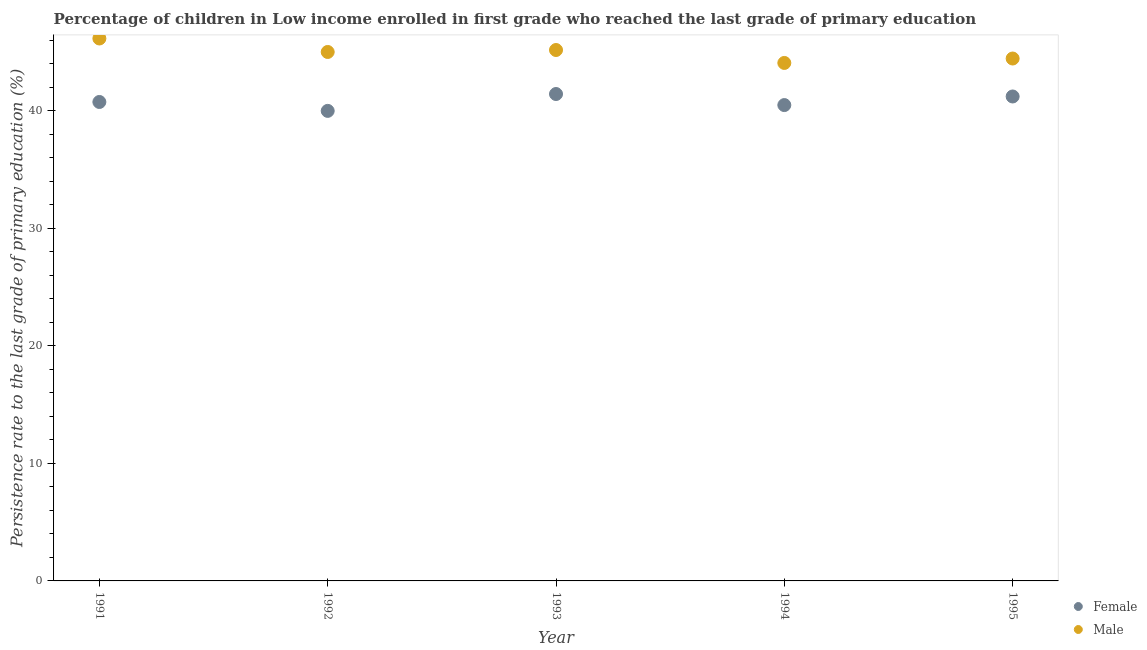Is the number of dotlines equal to the number of legend labels?
Ensure brevity in your answer.  Yes. What is the persistence rate of female students in 1995?
Your answer should be very brief. 41.22. Across all years, what is the maximum persistence rate of female students?
Provide a succinct answer. 41.43. Across all years, what is the minimum persistence rate of male students?
Your answer should be compact. 44.08. In which year was the persistence rate of male students maximum?
Make the answer very short. 1991. What is the total persistence rate of male students in the graph?
Offer a very short reply. 224.88. What is the difference between the persistence rate of male students in 1993 and that in 1994?
Your answer should be compact. 1.1. What is the difference between the persistence rate of male students in 1994 and the persistence rate of female students in 1992?
Provide a short and direct response. 4.08. What is the average persistence rate of male students per year?
Give a very brief answer. 44.98. In the year 1993, what is the difference between the persistence rate of female students and persistence rate of male students?
Offer a terse response. -3.74. In how many years, is the persistence rate of female students greater than 30 %?
Keep it short and to the point. 5. What is the ratio of the persistence rate of female students in 1991 to that in 1994?
Make the answer very short. 1.01. Is the difference between the persistence rate of male students in 1994 and 1995 greater than the difference between the persistence rate of female students in 1994 and 1995?
Provide a short and direct response. Yes. What is the difference between the highest and the second highest persistence rate of male students?
Make the answer very short. 0.98. What is the difference between the highest and the lowest persistence rate of female students?
Your response must be concise. 1.44. Is the persistence rate of male students strictly greater than the persistence rate of female students over the years?
Offer a terse response. Yes. How many dotlines are there?
Provide a succinct answer. 2. What is the difference between two consecutive major ticks on the Y-axis?
Provide a succinct answer. 10. Are the values on the major ticks of Y-axis written in scientific E-notation?
Provide a succinct answer. No. How many legend labels are there?
Your response must be concise. 2. How are the legend labels stacked?
Ensure brevity in your answer.  Vertical. What is the title of the graph?
Offer a terse response. Percentage of children in Low income enrolled in first grade who reached the last grade of primary education. What is the label or title of the Y-axis?
Your response must be concise. Persistence rate to the last grade of primary education (%). What is the Persistence rate to the last grade of primary education (%) in Female in 1991?
Provide a short and direct response. 40.76. What is the Persistence rate to the last grade of primary education (%) in Male in 1991?
Provide a short and direct response. 46.16. What is the Persistence rate to the last grade of primary education (%) of Female in 1992?
Give a very brief answer. 40. What is the Persistence rate to the last grade of primary education (%) in Male in 1992?
Ensure brevity in your answer.  45.01. What is the Persistence rate to the last grade of primary education (%) in Female in 1993?
Your answer should be very brief. 41.43. What is the Persistence rate to the last grade of primary education (%) of Male in 1993?
Give a very brief answer. 45.18. What is the Persistence rate to the last grade of primary education (%) in Female in 1994?
Keep it short and to the point. 40.49. What is the Persistence rate to the last grade of primary education (%) in Male in 1994?
Provide a short and direct response. 44.08. What is the Persistence rate to the last grade of primary education (%) in Female in 1995?
Provide a succinct answer. 41.22. What is the Persistence rate to the last grade of primary education (%) in Male in 1995?
Give a very brief answer. 44.45. Across all years, what is the maximum Persistence rate to the last grade of primary education (%) in Female?
Give a very brief answer. 41.43. Across all years, what is the maximum Persistence rate to the last grade of primary education (%) in Male?
Provide a succinct answer. 46.16. Across all years, what is the minimum Persistence rate to the last grade of primary education (%) of Female?
Keep it short and to the point. 40. Across all years, what is the minimum Persistence rate to the last grade of primary education (%) of Male?
Provide a succinct answer. 44.08. What is the total Persistence rate to the last grade of primary education (%) of Female in the graph?
Offer a terse response. 203.9. What is the total Persistence rate to the last grade of primary education (%) of Male in the graph?
Give a very brief answer. 224.88. What is the difference between the Persistence rate to the last grade of primary education (%) of Female in 1991 and that in 1992?
Your response must be concise. 0.76. What is the difference between the Persistence rate to the last grade of primary education (%) in Male in 1991 and that in 1992?
Your response must be concise. 1.15. What is the difference between the Persistence rate to the last grade of primary education (%) of Female in 1991 and that in 1993?
Make the answer very short. -0.68. What is the difference between the Persistence rate to the last grade of primary education (%) in Female in 1991 and that in 1994?
Ensure brevity in your answer.  0.26. What is the difference between the Persistence rate to the last grade of primary education (%) of Male in 1991 and that in 1994?
Give a very brief answer. 2.08. What is the difference between the Persistence rate to the last grade of primary education (%) in Female in 1991 and that in 1995?
Your response must be concise. -0.47. What is the difference between the Persistence rate to the last grade of primary education (%) in Male in 1991 and that in 1995?
Your answer should be very brief. 1.7. What is the difference between the Persistence rate to the last grade of primary education (%) of Female in 1992 and that in 1993?
Your answer should be compact. -1.44. What is the difference between the Persistence rate to the last grade of primary education (%) in Male in 1992 and that in 1993?
Offer a very short reply. -0.17. What is the difference between the Persistence rate to the last grade of primary education (%) in Female in 1992 and that in 1994?
Offer a terse response. -0.49. What is the difference between the Persistence rate to the last grade of primary education (%) of Male in 1992 and that in 1994?
Give a very brief answer. 0.93. What is the difference between the Persistence rate to the last grade of primary education (%) in Female in 1992 and that in 1995?
Your response must be concise. -1.23. What is the difference between the Persistence rate to the last grade of primary education (%) in Male in 1992 and that in 1995?
Provide a succinct answer. 0.56. What is the difference between the Persistence rate to the last grade of primary education (%) of Female in 1993 and that in 1994?
Ensure brevity in your answer.  0.94. What is the difference between the Persistence rate to the last grade of primary education (%) in Male in 1993 and that in 1994?
Ensure brevity in your answer.  1.1. What is the difference between the Persistence rate to the last grade of primary education (%) of Female in 1993 and that in 1995?
Ensure brevity in your answer.  0.21. What is the difference between the Persistence rate to the last grade of primary education (%) in Male in 1993 and that in 1995?
Offer a terse response. 0.72. What is the difference between the Persistence rate to the last grade of primary education (%) of Female in 1994 and that in 1995?
Keep it short and to the point. -0.73. What is the difference between the Persistence rate to the last grade of primary education (%) of Male in 1994 and that in 1995?
Keep it short and to the point. -0.38. What is the difference between the Persistence rate to the last grade of primary education (%) of Female in 1991 and the Persistence rate to the last grade of primary education (%) of Male in 1992?
Offer a very short reply. -4.25. What is the difference between the Persistence rate to the last grade of primary education (%) in Female in 1991 and the Persistence rate to the last grade of primary education (%) in Male in 1993?
Your response must be concise. -4.42. What is the difference between the Persistence rate to the last grade of primary education (%) in Female in 1991 and the Persistence rate to the last grade of primary education (%) in Male in 1994?
Offer a terse response. -3.32. What is the difference between the Persistence rate to the last grade of primary education (%) of Female in 1991 and the Persistence rate to the last grade of primary education (%) of Male in 1995?
Offer a terse response. -3.7. What is the difference between the Persistence rate to the last grade of primary education (%) of Female in 1992 and the Persistence rate to the last grade of primary education (%) of Male in 1993?
Offer a very short reply. -5.18. What is the difference between the Persistence rate to the last grade of primary education (%) of Female in 1992 and the Persistence rate to the last grade of primary education (%) of Male in 1994?
Offer a very short reply. -4.08. What is the difference between the Persistence rate to the last grade of primary education (%) of Female in 1992 and the Persistence rate to the last grade of primary education (%) of Male in 1995?
Provide a succinct answer. -4.46. What is the difference between the Persistence rate to the last grade of primary education (%) in Female in 1993 and the Persistence rate to the last grade of primary education (%) in Male in 1994?
Provide a succinct answer. -2.64. What is the difference between the Persistence rate to the last grade of primary education (%) in Female in 1993 and the Persistence rate to the last grade of primary education (%) in Male in 1995?
Offer a very short reply. -3.02. What is the difference between the Persistence rate to the last grade of primary education (%) in Female in 1994 and the Persistence rate to the last grade of primary education (%) in Male in 1995?
Keep it short and to the point. -3.96. What is the average Persistence rate to the last grade of primary education (%) of Female per year?
Provide a succinct answer. 40.78. What is the average Persistence rate to the last grade of primary education (%) in Male per year?
Make the answer very short. 44.98. In the year 1991, what is the difference between the Persistence rate to the last grade of primary education (%) in Female and Persistence rate to the last grade of primary education (%) in Male?
Your answer should be compact. -5.4. In the year 1992, what is the difference between the Persistence rate to the last grade of primary education (%) of Female and Persistence rate to the last grade of primary education (%) of Male?
Offer a terse response. -5.01. In the year 1993, what is the difference between the Persistence rate to the last grade of primary education (%) in Female and Persistence rate to the last grade of primary education (%) in Male?
Your answer should be very brief. -3.74. In the year 1994, what is the difference between the Persistence rate to the last grade of primary education (%) in Female and Persistence rate to the last grade of primary education (%) in Male?
Your answer should be very brief. -3.58. In the year 1995, what is the difference between the Persistence rate to the last grade of primary education (%) of Female and Persistence rate to the last grade of primary education (%) of Male?
Provide a succinct answer. -3.23. What is the ratio of the Persistence rate to the last grade of primary education (%) in Female in 1991 to that in 1992?
Offer a terse response. 1.02. What is the ratio of the Persistence rate to the last grade of primary education (%) of Male in 1991 to that in 1992?
Ensure brevity in your answer.  1.03. What is the ratio of the Persistence rate to the last grade of primary education (%) in Female in 1991 to that in 1993?
Offer a very short reply. 0.98. What is the ratio of the Persistence rate to the last grade of primary education (%) of Male in 1991 to that in 1993?
Provide a succinct answer. 1.02. What is the ratio of the Persistence rate to the last grade of primary education (%) in Male in 1991 to that in 1994?
Your answer should be compact. 1.05. What is the ratio of the Persistence rate to the last grade of primary education (%) in Female in 1991 to that in 1995?
Ensure brevity in your answer.  0.99. What is the ratio of the Persistence rate to the last grade of primary education (%) of Male in 1991 to that in 1995?
Ensure brevity in your answer.  1.04. What is the ratio of the Persistence rate to the last grade of primary education (%) in Female in 1992 to that in 1993?
Your answer should be compact. 0.97. What is the ratio of the Persistence rate to the last grade of primary education (%) in Male in 1992 to that in 1994?
Your answer should be compact. 1.02. What is the ratio of the Persistence rate to the last grade of primary education (%) in Female in 1992 to that in 1995?
Your answer should be compact. 0.97. What is the ratio of the Persistence rate to the last grade of primary education (%) of Male in 1992 to that in 1995?
Your answer should be very brief. 1.01. What is the ratio of the Persistence rate to the last grade of primary education (%) in Female in 1993 to that in 1994?
Your answer should be very brief. 1.02. What is the ratio of the Persistence rate to the last grade of primary education (%) of Female in 1993 to that in 1995?
Your answer should be compact. 1.01. What is the ratio of the Persistence rate to the last grade of primary education (%) in Male in 1993 to that in 1995?
Ensure brevity in your answer.  1.02. What is the ratio of the Persistence rate to the last grade of primary education (%) in Female in 1994 to that in 1995?
Give a very brief answer. 0.98. What is the difference between the highest and the second highest Persistence rate to the last grade of primary education (%) of Female?
Provide a short and direct response. 0.21. What is the difference between the highest and the second highest Persistence rate to the last grade of primary education (%) of Male?
Your answer should be very brief. 0.98. What is the difference between the highest and the lowest Persistence rate to the last grade of primary education (%) of Female?
Keep it short and to the point. 1.44. What is the difference between the highest and the lowest Persistence rate to the last grade of primary education (%) in Male?
Your answer should be very brief. 2.08. 